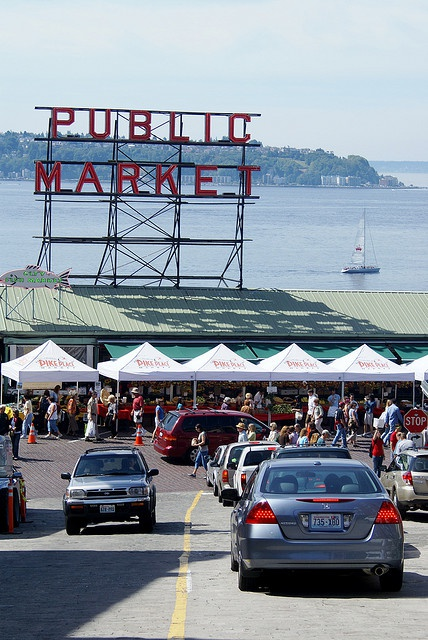Describe the objects in this image and their specific colors. I can see car in lightblue, navy, darkblue, black, and gray tones, people in lightblue, black, gray, maroon, and darkgray tones, car in lightblue, black, darkgray, navy, and gray tones, car in lightblue, black, maroon, gray, and brown tones, and car in lightblue, black, gray, darkgray, and lightgray tones in this image. 